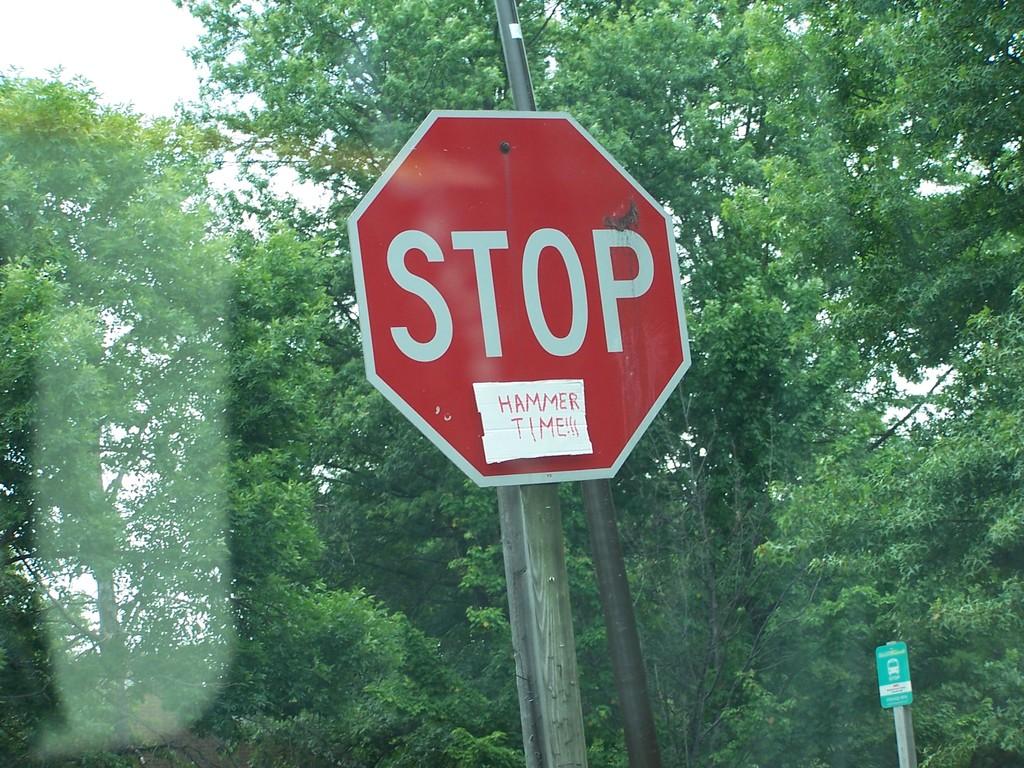What kind of traffic sign is this?
Ensure brevity in your answer.  Stop. What's the note below stop say?
Give a very brief answer. Hammer time. 